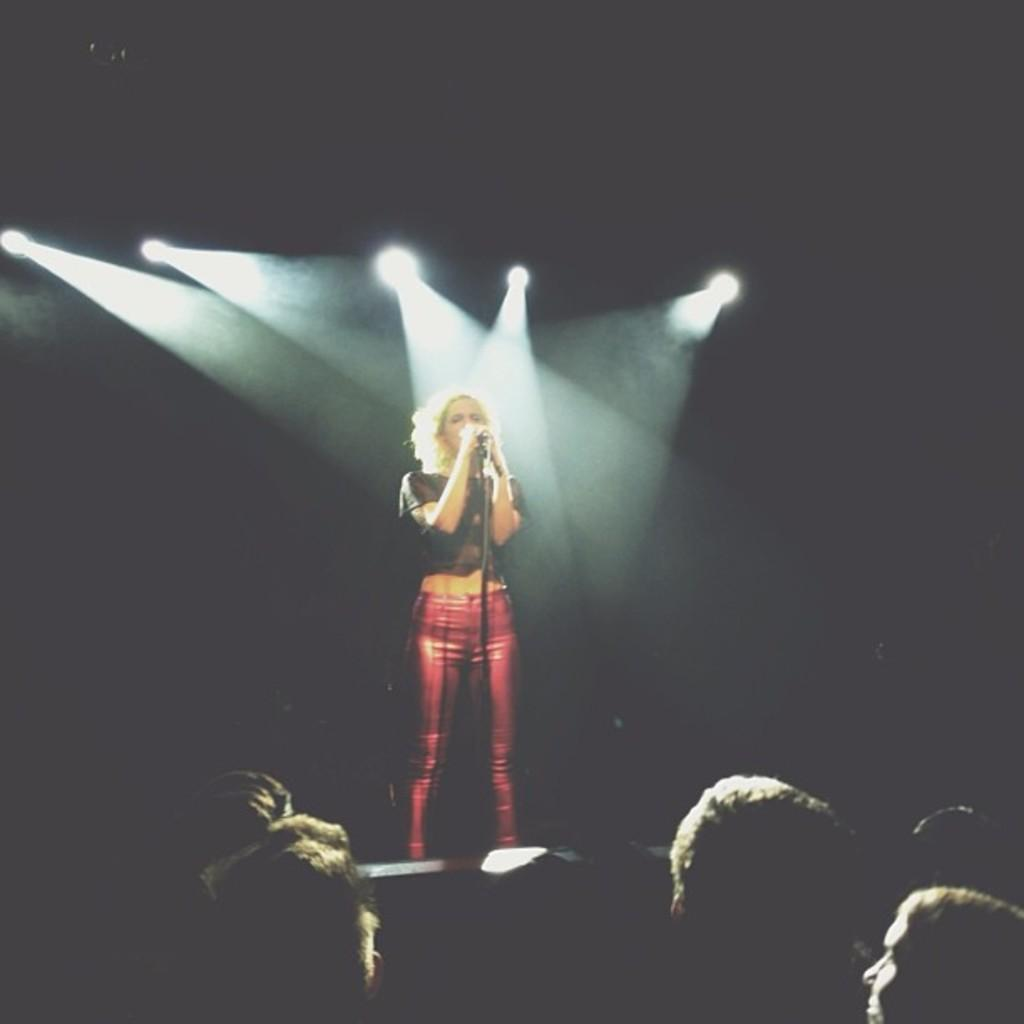What is the main subject of the image? There is a beautiful girl in the image. What is the girl doing in the image? The girl is standing and singing. What object is the girl using while singing? There is a microphone in the image. What can be seen in the background of the image? There are lights visible in the image. Can you tell me how many sea creatures are swimming near the girl in the image? There are no sea creatures present in the image; it features a girl singing with a microphone and lights in the background. What type of vein is visible on the girl's arm in the image? There is no visible vein on the girl's arm in the image. 